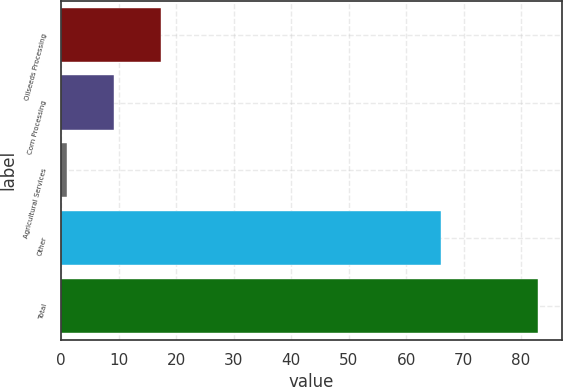<chart> <loc_0><loc_0><loc_500><loc_500><bar_chart><fcel>Oilseeds Processing<fcel>Corn Processing<fcel>Agricultural Services<fcel>Other<fcel>Total<nl><fcel>17.4<fcel>9.2<fcel>1<fcel>66<fcel>83<nl></chart> 